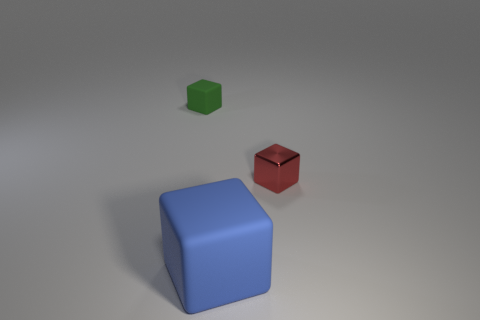Do the small rubber thing and the object in front of the tiny red thing have the same color?
Give a very brief answer. No. What number of green rubber objects are behind the rubber object on the left side of the big blue object?
Your answer should be compact. 0. Is there anything else that has the same material as the tiny red object?
Offer a very short reply. No. There is a block that is behind the small block that is in front of the tiny thing that is on the left side of the tiny red thing; what is it made of?
Your response must be concise. Rubber. The cube that is both behind the blue matte cube and to the right of the small green thing is made of what material?
Keep it short and to the point. Metal. How many other large blue matte objects have the same shape as the blue thing?
Provide a short and direct response. 0. There is a matte block behind the small object that is on the right side of the green thing; how big is it?
Offer a very short reply. Small. There is a small block that is in front of the small thing behind the red thing; what number of blue blocks are in front of it?
Give a very brief answer. 1. What number of cubes are both to the left of the red shiny object and behind the blue cube?
Offer a very short reply. 1. Is the number of things that are to the left of the tiny red metallic block greater than the number of tiny gray objects?
Offer a terse response. Yes. 